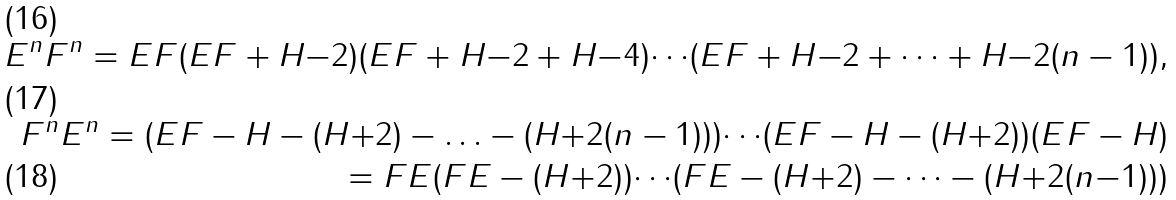<formula> <loc_0><loc_0><loc_500><loc_500>E ^ { n } F ^ { n } = E F ( E F + H { - } 2 ) ( E F + H { - } 2 + H { - } 4 ) { \cdots } ( E F + H { - } 2 + { \cdots } + H { - } 2 ( n - 1 ) ) , \\ F ^ { n } E ^ { n } = ( E F - H - ( H { + } 2 ) - { \dots } - ( H { + } 2 ( n - 1 ) ) ) { \cdots } ( E F - H - ( H { + } 2 ) ) ( E F - H ) \\ = F E ( F E - ( H { + } 2 ) ) { \cdots } ( F E - ( H { + } 2 ) - { \cdots } - ( H { + } 2 ( n { - } 1 ) ) )</formula> 